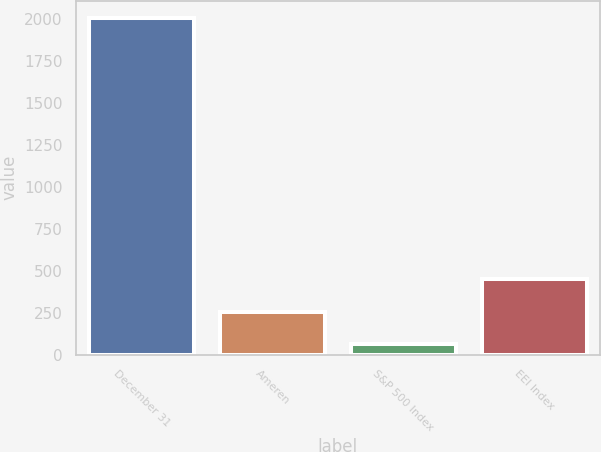<chart> <loc_0><loc_0><loc_500><loc_500><bar_chart><fcel>December 31<fcel>Ameren<fcel>S&P 500 Index<fcel>EEI Index<nl><fcel>2008<fcel>257.5<fcel>63<fcel>452<nl></chart> 